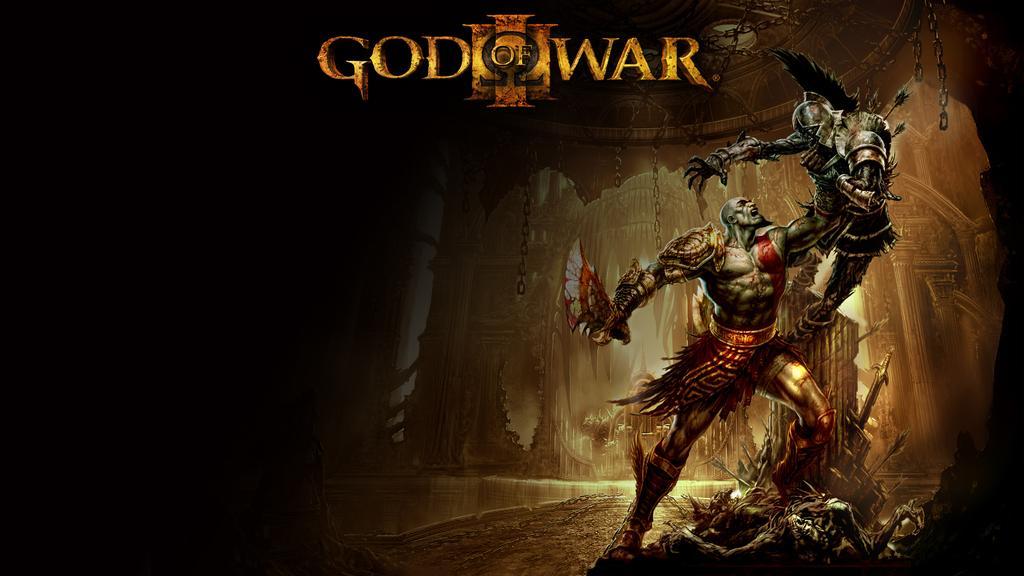Can you describe this image briefly? In this image I can see two statues, they are in gray and red color. Background I can see a building in brown color and I can see something written on the image. 